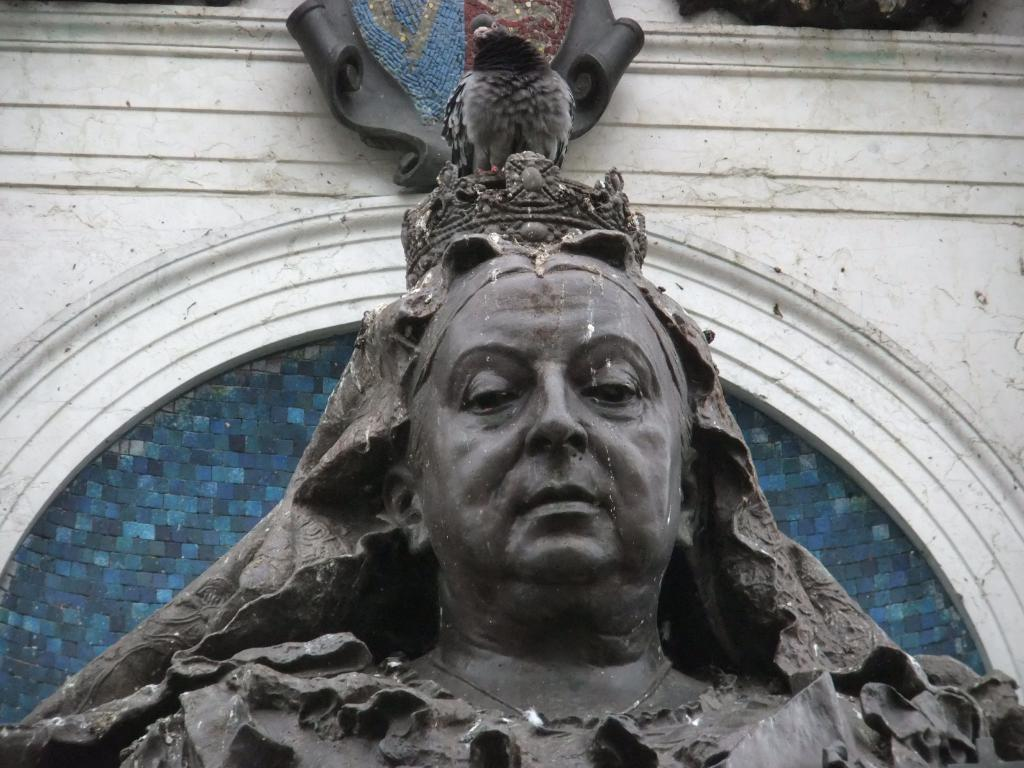What type of animal is in the image? There is a pigeon in the image. Where is the pigeon located? The pigeon is standing on a statue. What can be seen in the background of the image? There is a wall in the background of the image. What type of brain can be seen in the image? There is no brain present in the image; it features a pigeon standing on a statue with a wall in the background. 